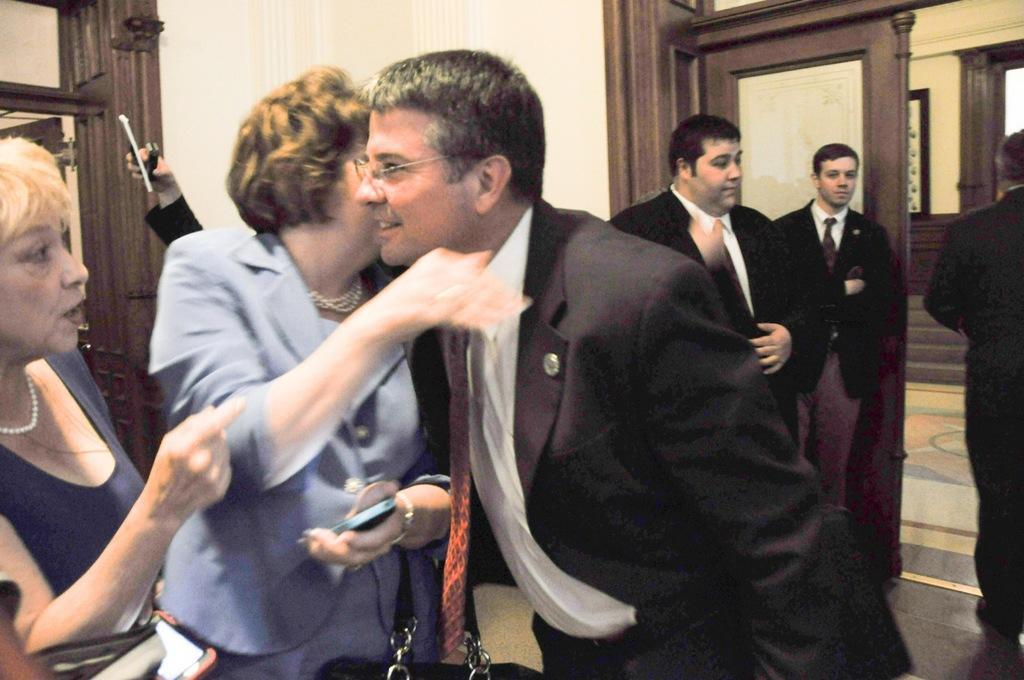How would you summarize this image in a sentence or two? In this image I can see on the right side few men are standing, they are wearing coats, ties, shirts. In the middle a man is hugging a woman, on the left side there is a woman, she is talking. 